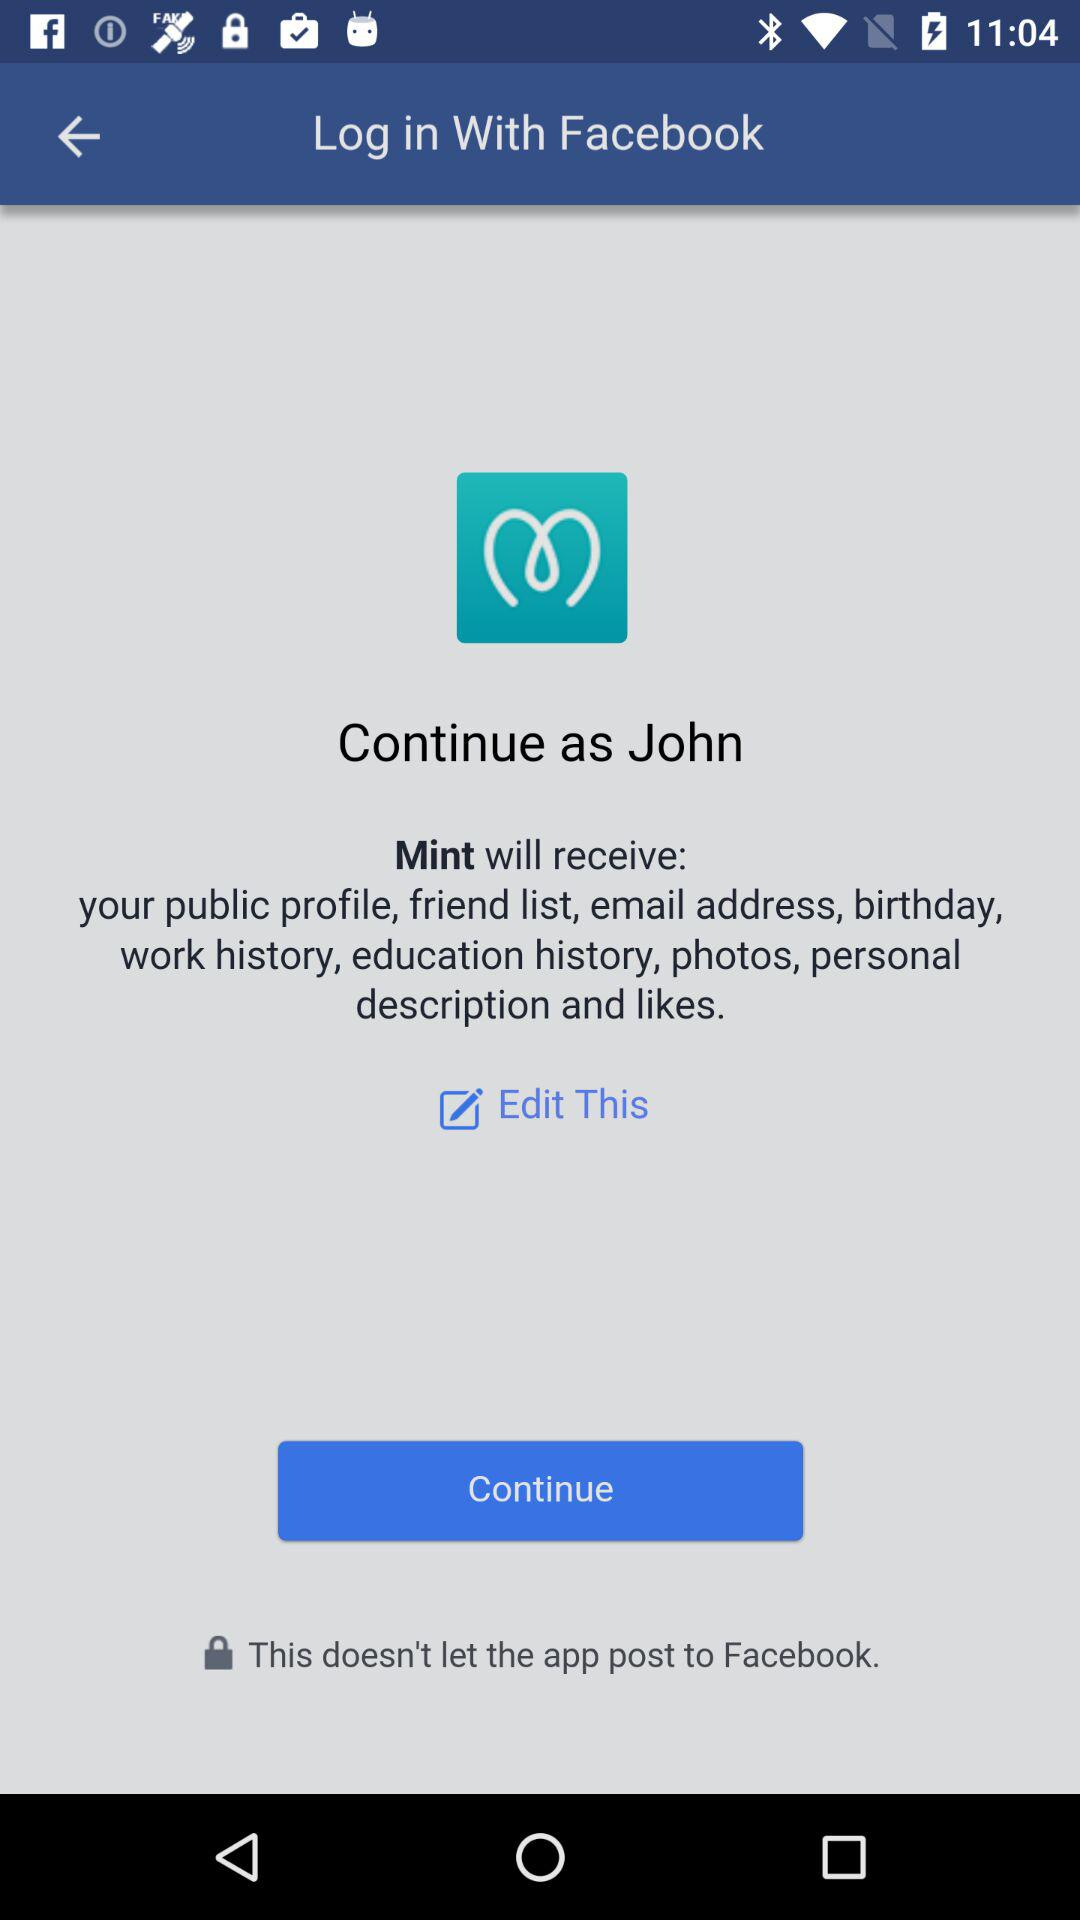What application can be used to log in? We can use Facebook to log in. 